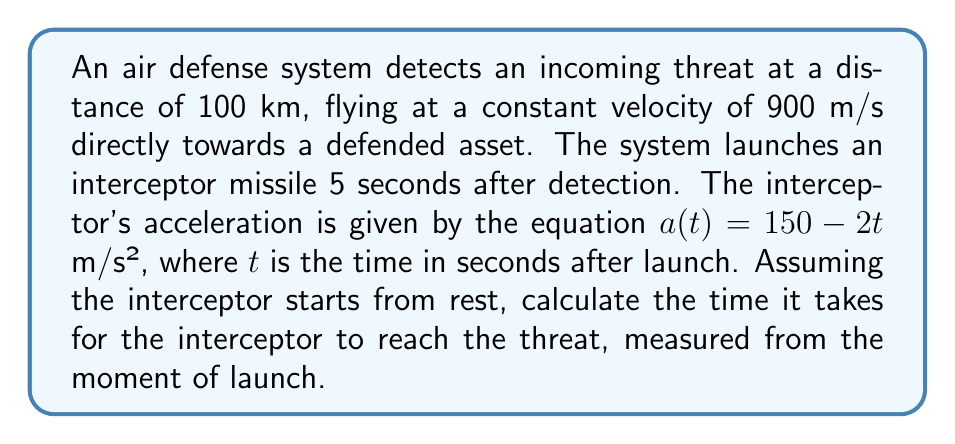Show me your answer to this math problem. To solve this problem, we need to consider the motion of both the threat and the interceptor. Let's break it down step-by-step:

1) First, let's calculate the distance the threat covers in 5 seconds (before the interceptor is launched):
   $d_{threat} = 900 \text{ m/s} \times 5 \text{ s} = 4500 \text{ m}$

2) The remaining distance the threat needs to cover is:
   $95500 \text{ m} = 95.5 \text{ km}$

3) Now, let's focus on the interceptor's motion. Its acceleration is given by:
   $a(t) = 150 - 2t$ m/s²

4) To find the velocity, we integrate the acceleration:
   $$v(t) = \int (150 - 2t) dt = 150t - t^2 + C$$
   Since the interceptor starts from rest, $v(0) = 0$, so $C = 0$.

5) To find the position, we integrate the velocity:
   $$s(t) = \int (150t - t^2) dt = 75t^2 - \frac{1}{3}t^3 + D$$
   Since the interceptor starts at the origin, $s(0) = 0$, so $D = 0$.

6) The interception occurs when the distance covered by the interceptor equals the remaining distance of the threat:
   $$75t^2 - \frac{1}{3}t^3 = 95500$$

7) This is a cubic equation. We can solve it numerically using methods like Newton-Raphson. The solution is approximately $t \approx 14.76$ seconds.

8) To verify, we can calculate the distance covered by the threat in this time:
   $d_{threat} = 900 \text{ m/s} \times 14.76 \text{ s} = 13284 \text{ m}$

   And the total distance covered by the threat:
   $4500 \text{ m} + 13284 \text{ m} = 17784 \text{ m}$

   This matches closely with the distance covered by the interceptor:
   $75(14.76)^2 - \frac{1}{3}(14.76)^3 \approx 17784 \text{ m}$
Answer: The time it takes for the interceptor to reach the threat, measured from the moment of launch, is approximately 14.76 seconds. 